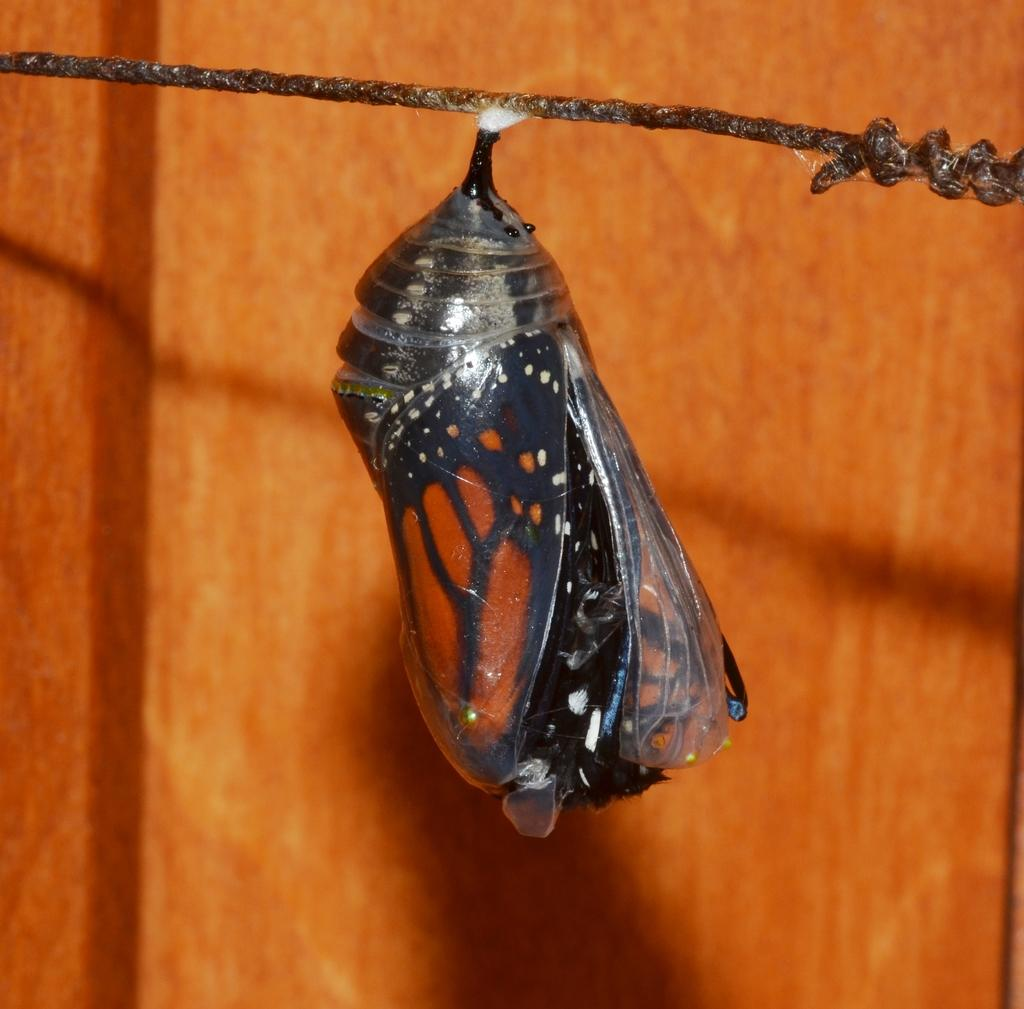What type of animal can be seen in the image? There is a butterfly in the image. What object is present in the image that is typically used for tying or securing things? There is a rope in the image. What can be seen in the background of the image? There is a wall visible in the background of the image. How many bridges are visible in the image? There are no bridges present in the image. What type of power source can be seen in the image? There is no power source visible in the image. 